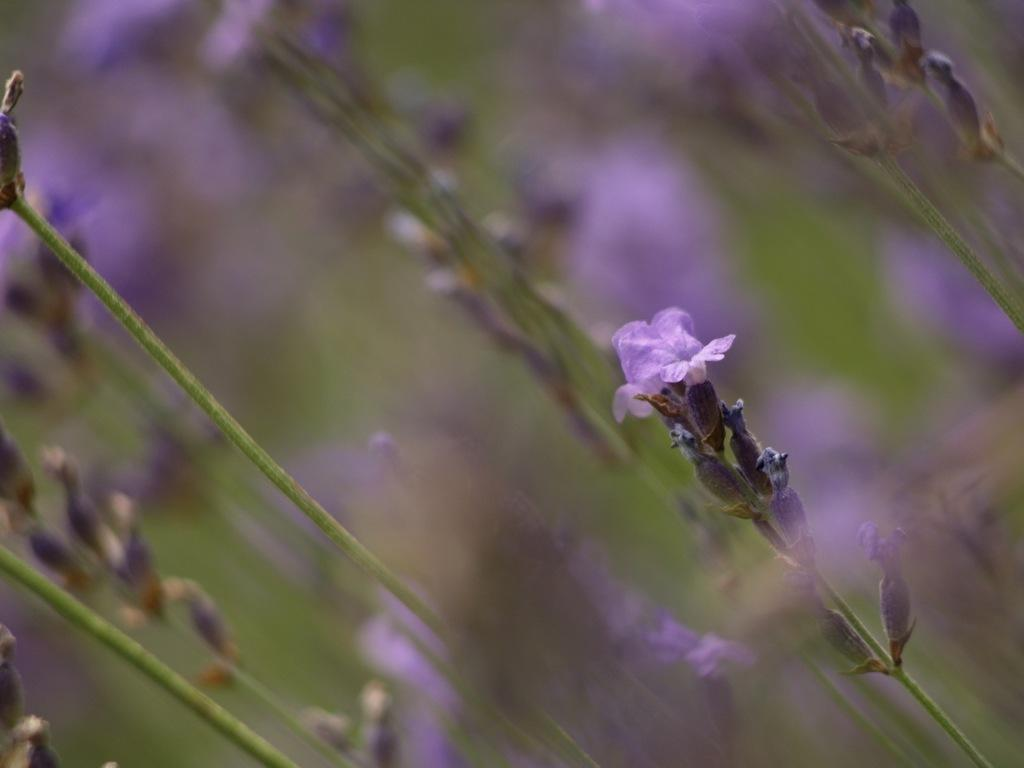What can be observed about the image's appearance? The image is edited. What type of vegetation is present in the image? There are plants with flowers in the image. What type of flame can be seen on the lawyer's wing in the image? There is no lawyer or wing present in the image, and therefore no flame can be observed. 